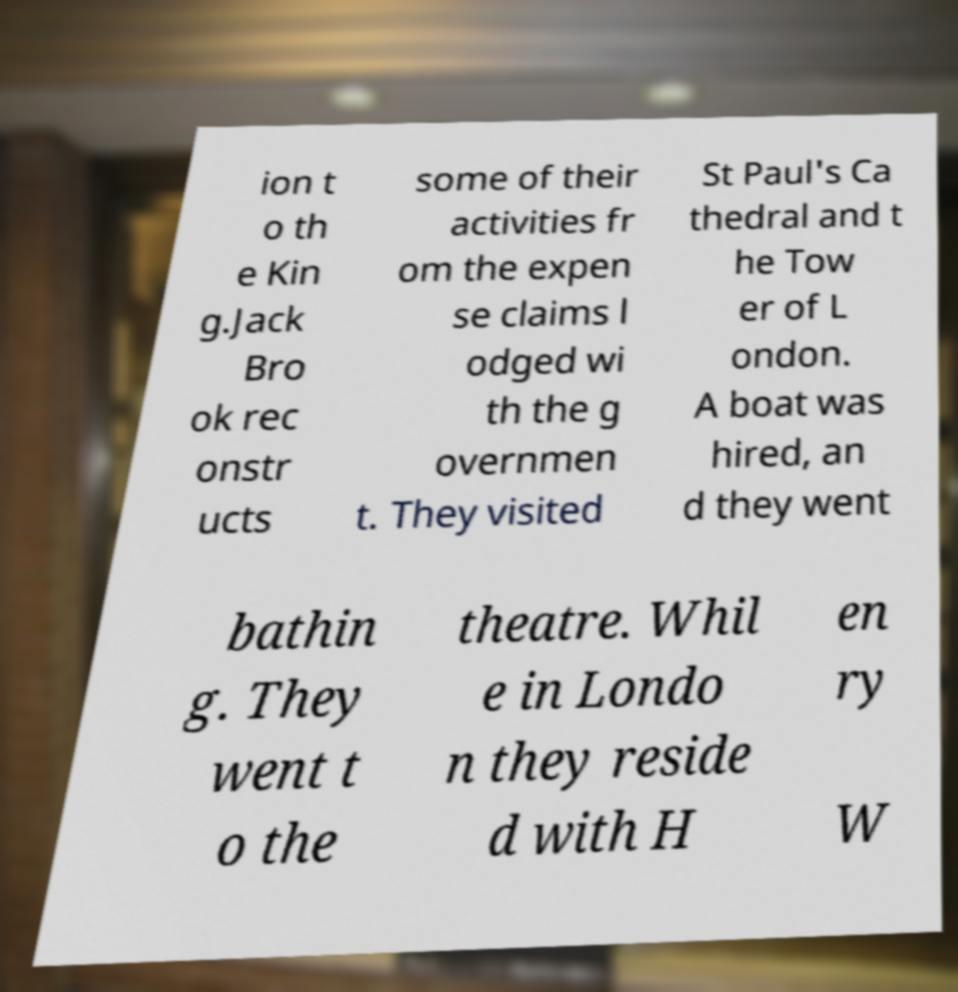Please identify and transcribe the text found in this image. ion t o th e Kin g.Jack Bro ok rec onstr ucts some of their activities fr om the expen se claims l odged wi th the g overnmen t. They visited St Paul's Ca thedral and t he Tow er of L ondon. A boat was hired, an d they went bathin g. They went t o the theatre. Whil e in Londo n they reside d with H en ry W 